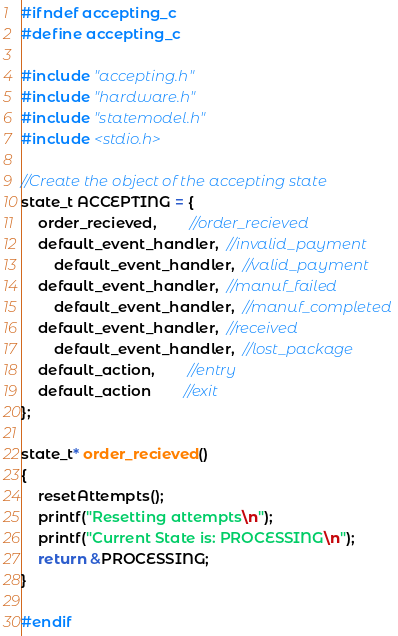<code> <loc_0><loc_0><loc_500><loc_500><_C_>
#ifndef accepting_c
#define accepting_c

#include "accepting.h"
#include "hardware.h"
#include "statemodel.h"
#include <stdio.h>

//Create the object of the accepting state
state_t ACCEPTING = {
	order_recieved,		//order_recieved
	default_event_handler,  //invalid_payment
        default_event_handler,  //valid_payment
	default_event_handler,  //manuf_failed
        default_event_handler,  //manuf_completed
	default_event_handler,  //received
        default_event_handler,  //lost_package
	default_action,		//entry
	default_action		//exit
};

state_t* order_recieved()
{
	resetAttempts();
	printf("Resetting attempts\n");
	printf("Current State is: PROCESSING\n");
	return &PROCESSING;
}

#endif
</code> 